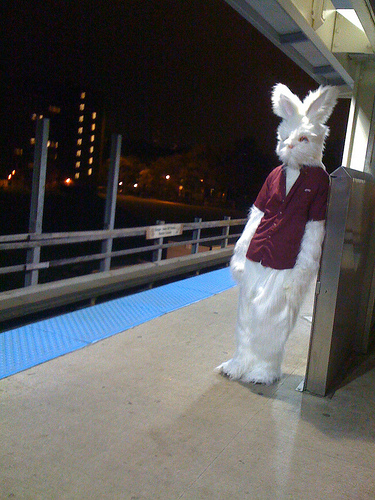<image>
Can you confirm if the shirt is on the rabbit? Yes. Looking at the image, I can see the shirt is positioned on top of the rabbit, with the rabbit providing support. 